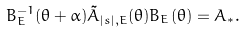<formula> <loc_0><loc_0><loc_500><loc_500>B _ { E } ^ { - 1 } ( \theta + \alpha ) \tilde { A } _ { | s | , E } ( \theta ) B _ { E } ( \theta ) = A _ { * } .</formula> 